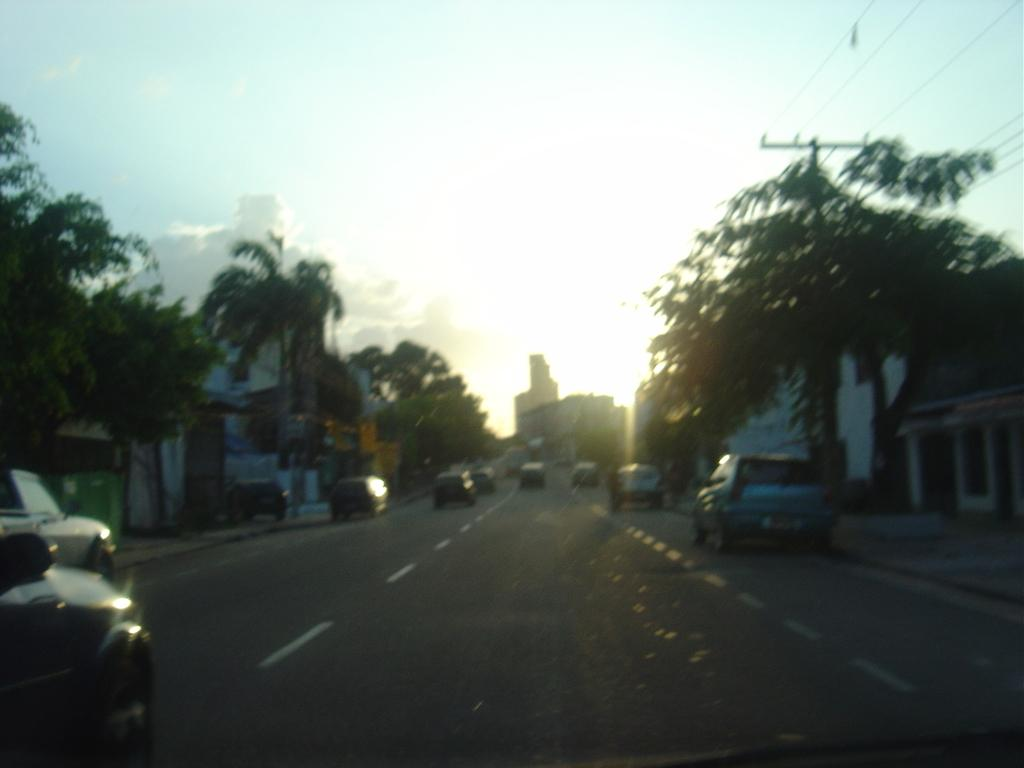What type of vehicles can be seen on the road in the image? There are cars on the road in the image. What other elements can be seen in the image besides the cars? There are trees, buildings, a pole, and the sky visible in the image. Can you describe the sky in the image? The sky is visible in the background, and clouds are present in the sky. What type of orange is being sorted by the actor in the image? There is no orange or actor present in the image. 